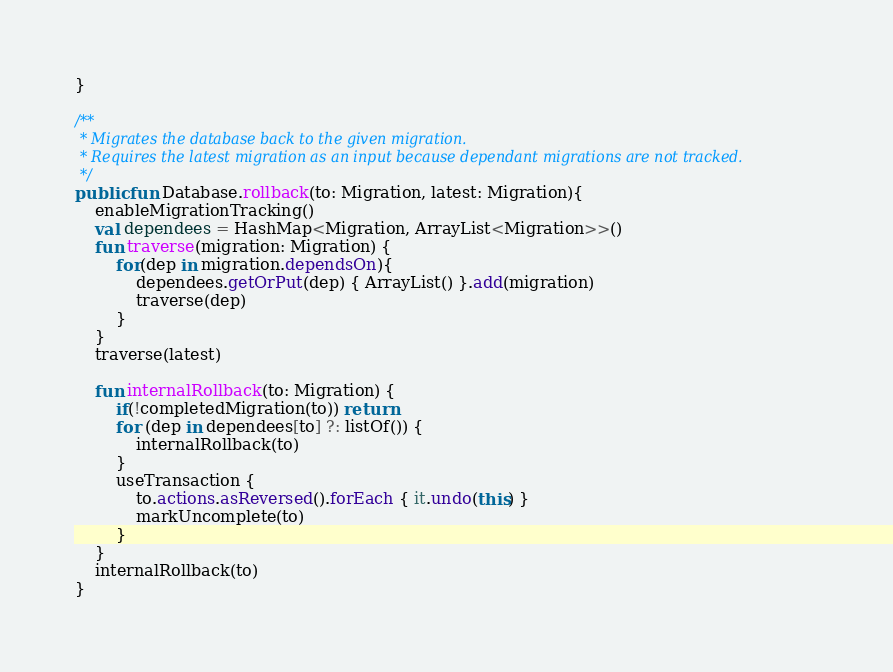Convert code to text. <code><loc_0><loc_0><loc_500><loc_500><_Kotlin_>}

/**
 * Migrates the database back to the given migration.
 * Requires the latest migration as an input because dependant migrations are not tracked.
 */
public fun Database.rollback(to: Migration, latest: Migration){
    enableMigrationTracking()
    val dependees = HashMap<Migration, ArrayList<Migration>>()
    fun traverse(migration: Migration) {
        for(dep in migration.dependsOn){
            dependees.getOrPut(dep) { ArrayList() }.add(migration)
            traverse(dep)
        }
    }
    traverse(latest)

    fun internalRollback(to: Migration) {
        if(!completedMigration(to)) return
        for (dep in dependees[to] ?: listOf()) {
            internalRollback(to)
        }
        useTransaction {
            to.actions.asReversed().forEach { it.undo(this) }
            markUncomplete(to)
        }
    }
    internalRollback(to)
}</code> 